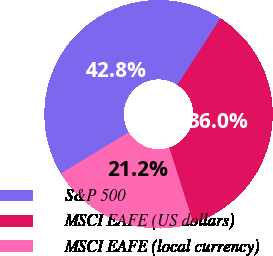Convert chart. <chart><loc_0><loc_0><loc_500><loc_500><pie_chart><fcel>S&P 500<fcel>MSCI EAFE (US dollars)<fcel>MSCI EAFE (local currency)<nl><fcel>42.82%<fcel>35.95%<fcel>21.22%<nl></chart> 